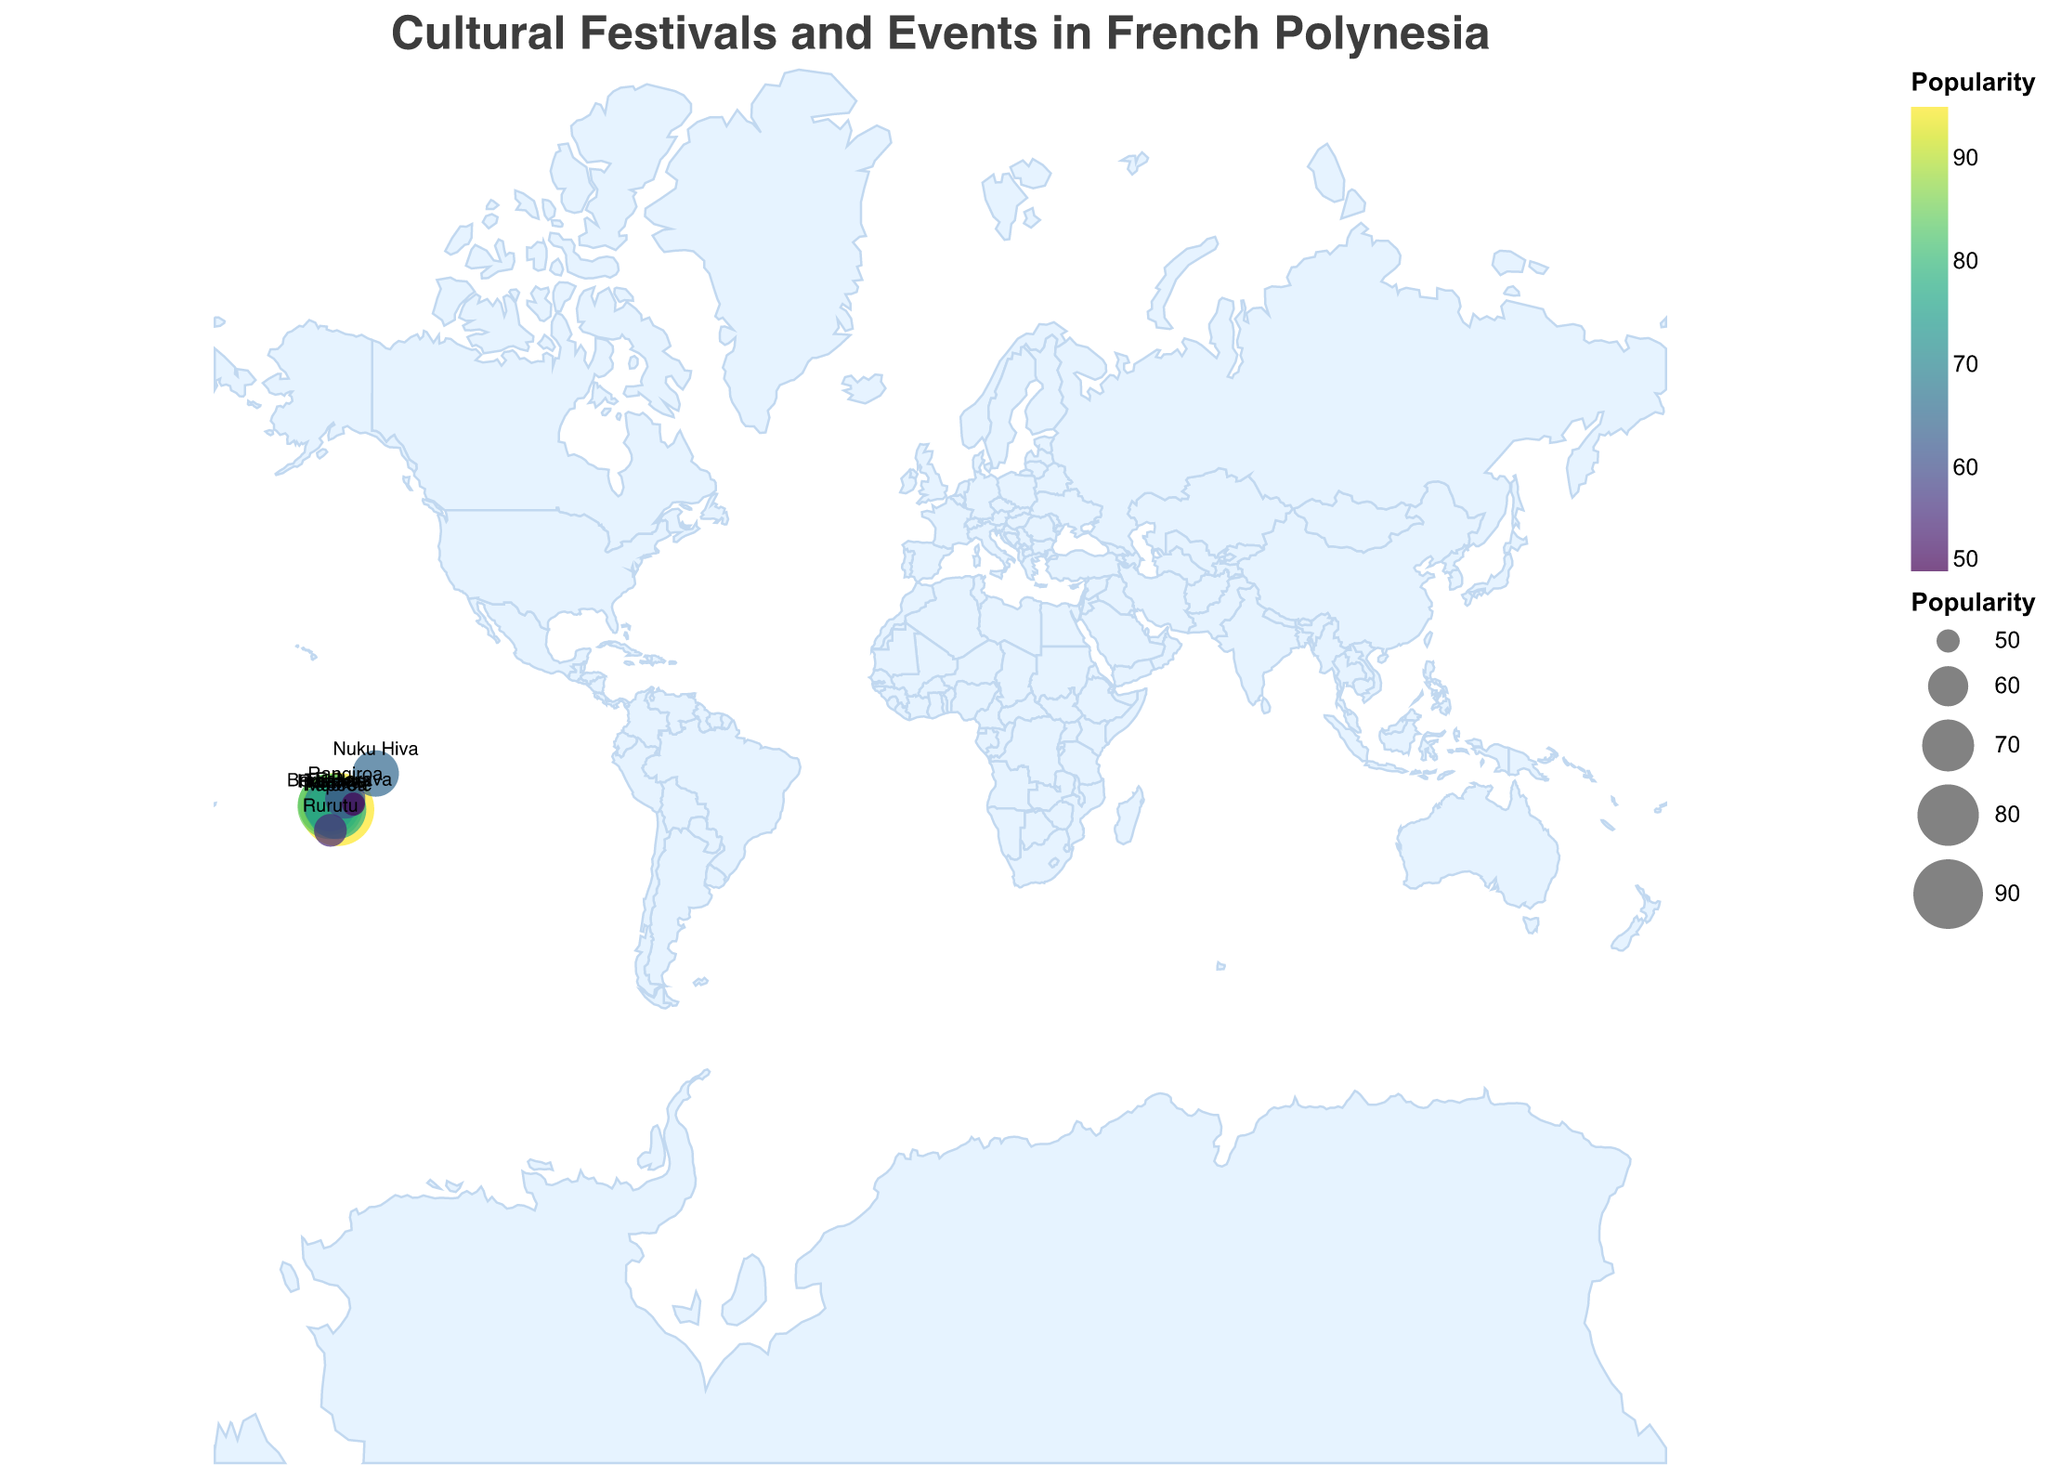What is the title of the figure? The title is displayed at the top of the figure in a larger font. It provides an overview of what the plot is about. The title reads "Cultural Festivals and Events in French Polynesia".
Answer: Cultural Festivals and Events in French Polynesia Which event is the most popular according to the plot? We need to look for the largest circle and the highest color intensity in the plot. According to the plot, "Heiva i Tahiti" in Papeete has the highest popularity, symbolized by the largest circle and the most intense color.
Answer: Heiva i Tahiti What are the latitude and longitude coordinates of the Bora Bora Liquid Festival? The plot includes labels for each location, and selecting Bora Bora will reveal the coordinates directly in the tooltip. For Bora Bora Liquid Festival, the coordinates are -16.5004 (Latitude) and -151.7415 (Longitude).
Answer: -16.5004 and -151.7415 Which location has the least popular event? We need to find the smallest circle with the least color intensity. The "Fakarava Lagoon Race" in Fakarava has a popularity of 50, which is the lowest on the plot.
Answer: Fakarava What is the combined popularity of events in Huahine and Raiatea? Huahine has a popularity of 75 and Raiatea has 85. Adding these gives us 75 + 85 = 160.
Answer: 160 Which events are located closest to each other? By visually examining the plot, it appears that events in Raiatea and Tahaa are closest to each other geographically based on their nearby positions.
Answer: Hawaiki Nui Va'a and Vanilla Festival How many events have a popularity score greater than 70? By counting the circles with sizes indicating popularity greater than 70, we get events in Papeete, Bora Bora, Huahine, Raiatea, and Moorea, which totals to five events.
Answer: Five What is the difference in popularity between the most popular and least popular events? The most popular event has a popularity of 95 (Heiva i Tahiti), and the least popular has 50 (Fakarava). The difference is 95 - 50 = 45.
Answer: 45 